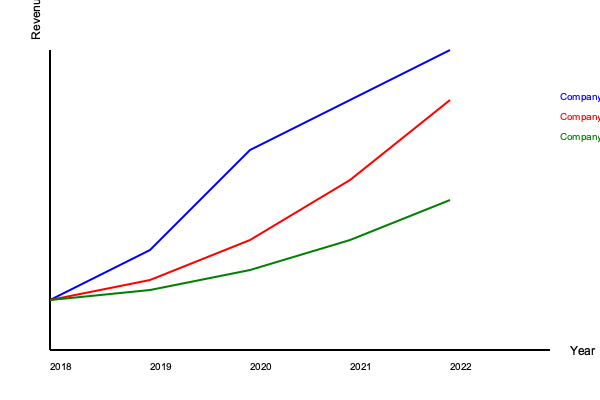Based on the line graph showing revenue growth for Companies A, B, and C from 2018 to 2022, which company has demonstrated the most consistent year-over-year growth rate? To determine the most consistent year-over-year growth rate, we need to analyze the slope of each company's line:

1. Company A (blue line):
   - Steep increase from 2018 to 2020
   - Less steep but still significant increase from 2020 to 2022
   - Growth rate varies considerably

2. Company B (red line):
   - Gradual increase from 2018 to 2020
   - Steeper increase from 2020 to 2022
   - Growth rate accelerates over time

3. Company C (green line):
   - Slight increase from 2018 to 2020
   - Slightly steeper increase from 2020 to 2022
   - Most consistent slope throughout the entire period

Comparing the three companies:
- Company A shows the highest overall growth but with varying rates
- Company B shows accelerating growth
- Company C shows the most consistent slope, indicating the most stable year-over-year growth rate

Therefore, Company C demonstrates the most consistent year-over-year growth rate.
Answer: Company C 